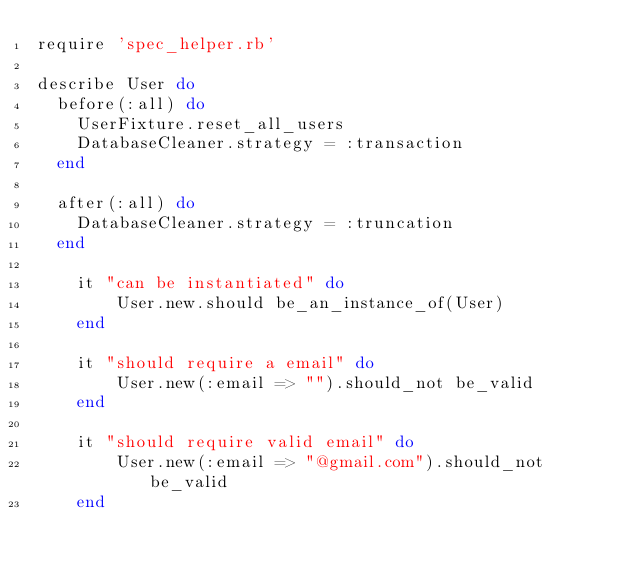<code> <loc_0><loc_0><loc_500><loc_500><_Ruby_>require 'spec_helper.rb'

describe User do
  before(:all) do
    UserFixture.reset_all_users
    DatabaseCleaner.strategy = :transaction
  end

  after(:all) do
    DatabaseCleaner.strategy = :truncation
  end

	it "can be instantiated" do
		User.new.should be_an_instance_of(User)
	end

	it "should require a email" do
  		User.new(:email => "").should_not be_valid
	end

	it "should require valid email" do
		User.new(:email => "@gmail.com").should_not be_valid
	end
</code> 